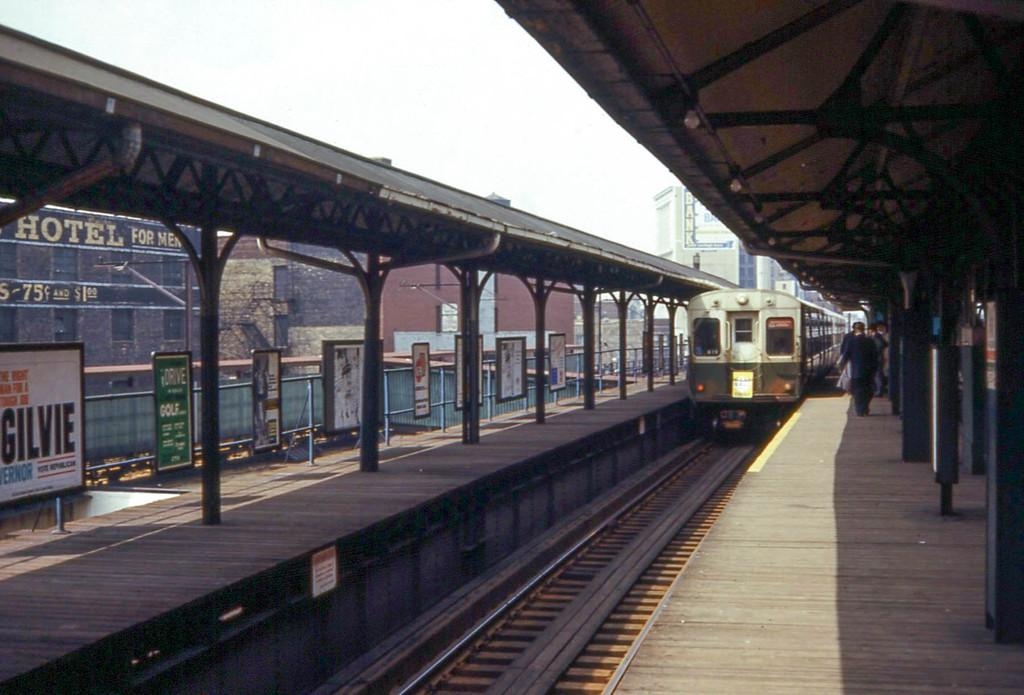What is the main subject in the foreground of the image? There is a train in the foreground of the image. What is the train's position in relation to the track? The train is on a track. What can be seen on the platform in the foreground of the image? There is a crowd on a platform in the foreground of the image. What type of structures are visible in the background of the image? There are buildings and hotels in the background of the image. What other objects can be seen in the background of the image? There are boards in the background of the image. What is visible in the sky in the background of the image? The sky is visible in the background of the image. When was the image taken? The image was taken during the day. Can you see any ghosts swimming in the image? There are no ghosts or swimming activities depicted in the image. 